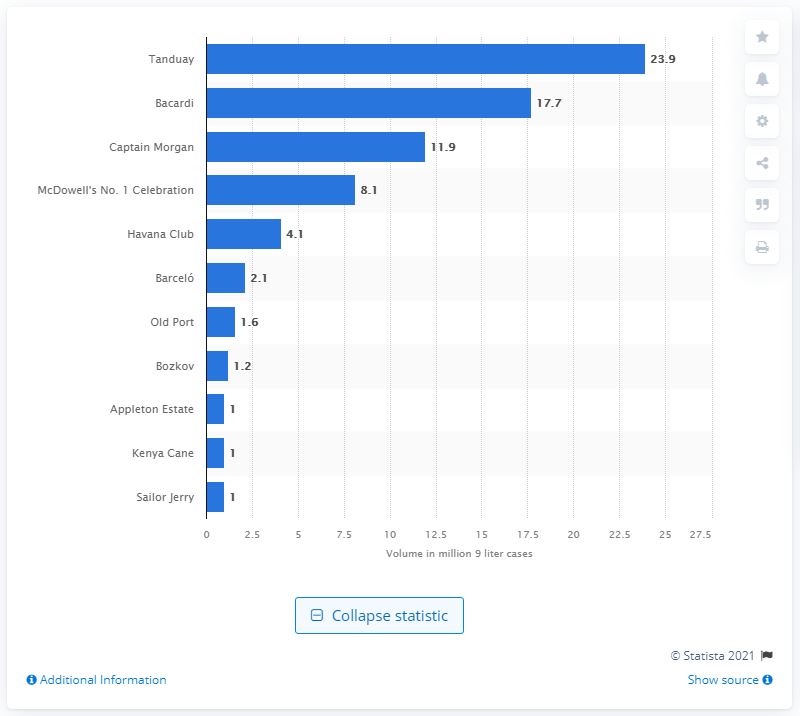Identify some key points in this picture. Bacardi's sales volume in 2020 was 17.7 billion. Bacardi was the second largest global rum brand in 2020. 